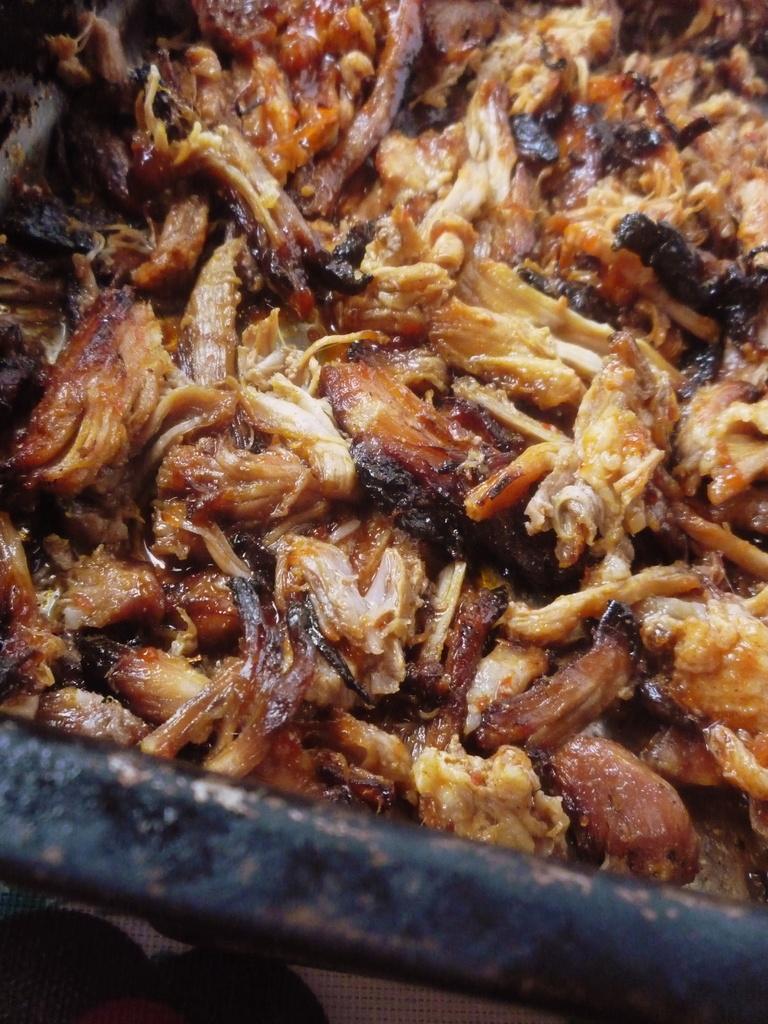Describe this image in one or two sentences. In this image we can see some food item in an object, which looks a pan. 